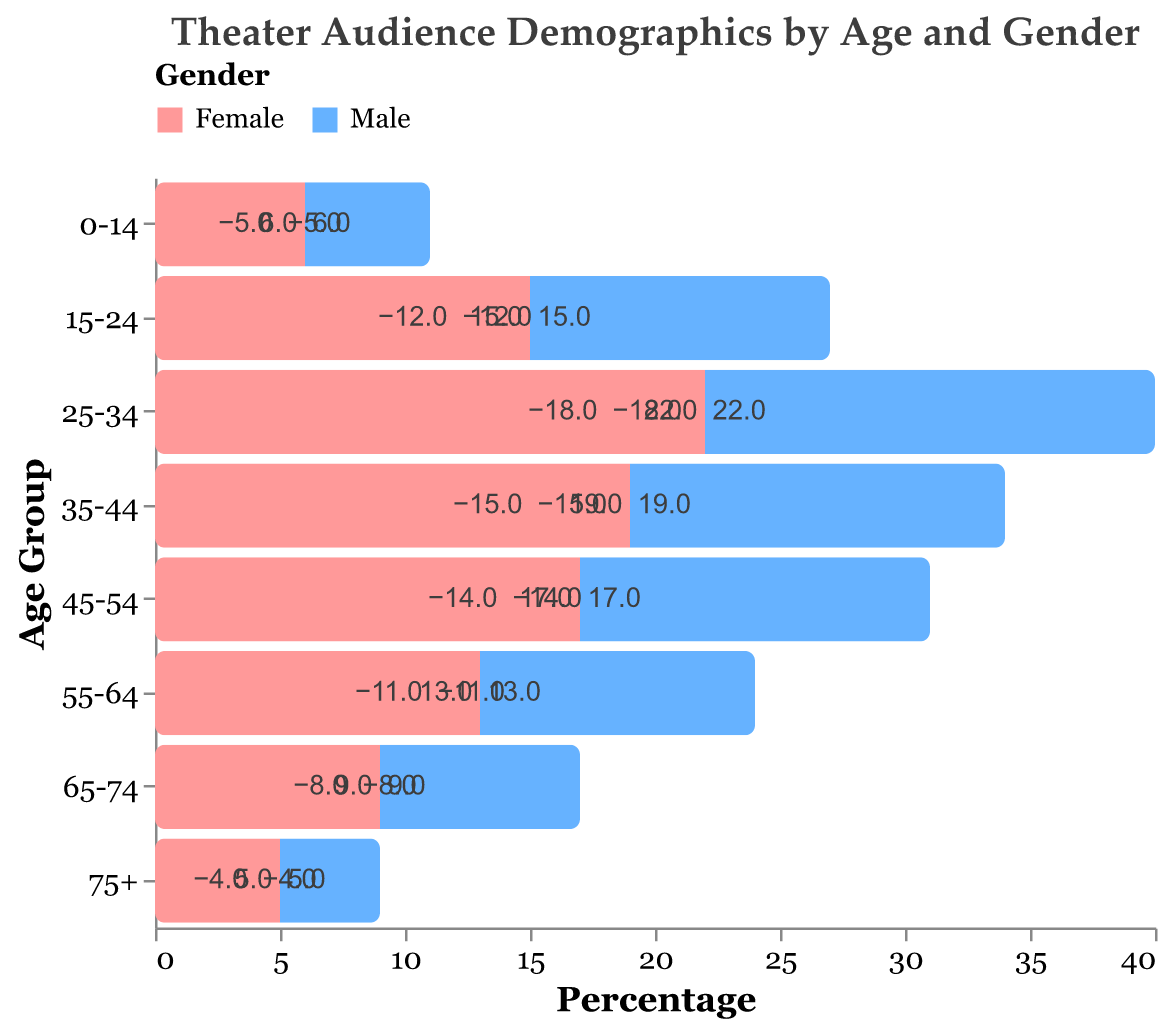What is the title of the figure? The title is usually displayed at the top of the figure to give an overview of what the data represents. The title here describes the demographics of theater audiences by age and gender.
Answer: Theater Audience Demographics by Age and Gender Which age group has the highest percentage of female theatergoers? By examining the bars on the right side (female) of the figure, observe which age group extends the furthest. The 25-34 age group has the largest percentage for females.
Answer: 25-34 What is the total percentage of male theatergoers aged 15-24 and 25-34 combined? Add the absolute values of the percentages of males in the 15-24 and 25-34 age groups: 12 + 18 = 30.
Answer: 30 Which gender has a higher percentage in the 65-74 age group, and by how much? Compare the lengths of the bars for males and females in the 65-74 age group. Females have a bar extending to 9, while males have a bar extending to 8 (absolute value). The difference is 9 - 8 = 1.
Answer: Female, by 1 What is the age group with the lowest percentage of male theatergoers? By examining the length of the bars on the left side (male), the age group 75+ has the shortest bar, indicating the lowest percentage of male theatergoers.
Answer: 75+ How does the percentage of female theatergoers aged 35-44 compare to that of males in the same age group? Compare the lengths of the bars for males and females in the 35-44 age group. Females have a bar extending to 19, while males have a bar extending to 15 (absolute value). Females have a higher percentage.
Answer: Females have 4% more What is the average percentage of female theatergoers aged 0-14, 15-24, and 25-34? Calculate the average by summing the percentages and dividing by the number of groups: (6 + 15 + 22) / 3 = 43 / 3 ≈ 14.3.
Answer: 14.3% In which age group is the difference between male and female theatergoers the largest? Calculate the absolute difference between male and female percentages in each age group. The 25-34 age group has the largest difference (22 - 18 = 4).
Answer: 25-34 How does the percentage of male theatergoers change as age increases from 55-64 to 75+? Observe the left side bars for the age groups 55-64, 65-74, and 75+. The values are -11, -8, and -4. The percentage decreases as age increases.
Answer: Decreases as age increases 